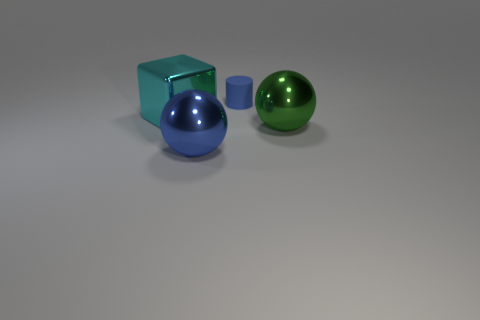Is there any other thing that has the same size as the blue matte thing?
Provide a short and direct response. No. Is the blue metallic object the same shape as the large cyan metallic thing?
Offer a very short reply. No. What is the material of the cube?
Offer a very short reply. Metal. What number of big things are both to the left of the rubber thing and to the right of the cube?
Offer a very short reply. 1. Is the size of the green shiny ball the same as the cyan metallic block?
Your response must be concise. Yes. Is the size of the object behind the metallic cube the same as the green metallic sphere?
Give a very brief answer. No. What color is the object behind the cyan block?
Offer a terse response. Blue. How many tiny purple rubber cylinders are there?
Ensure brevity in your answer.  0. There is a large blue object that is the same material as the large cyan block; what is its shape?
Keep it short and to the point. Sphere. There is a large sphere behind the big blue thing; is it the same color as the large metal thing in front of the green ball?
Offer a terse response. No. 